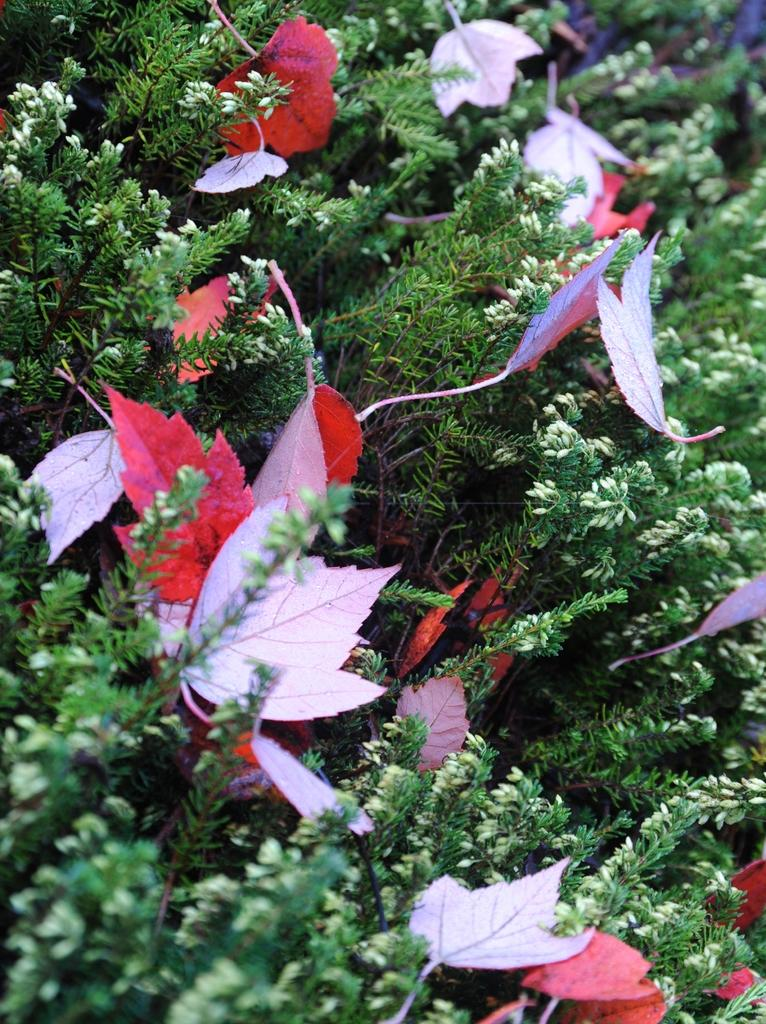What type of plants can be seen in the image? There are green plants in the image. What color are the leaves on the plants? The leaves on the plants are red. How many teeth can be seen in the image? There are no teeth present in the image; it features green plants with red leaves. 